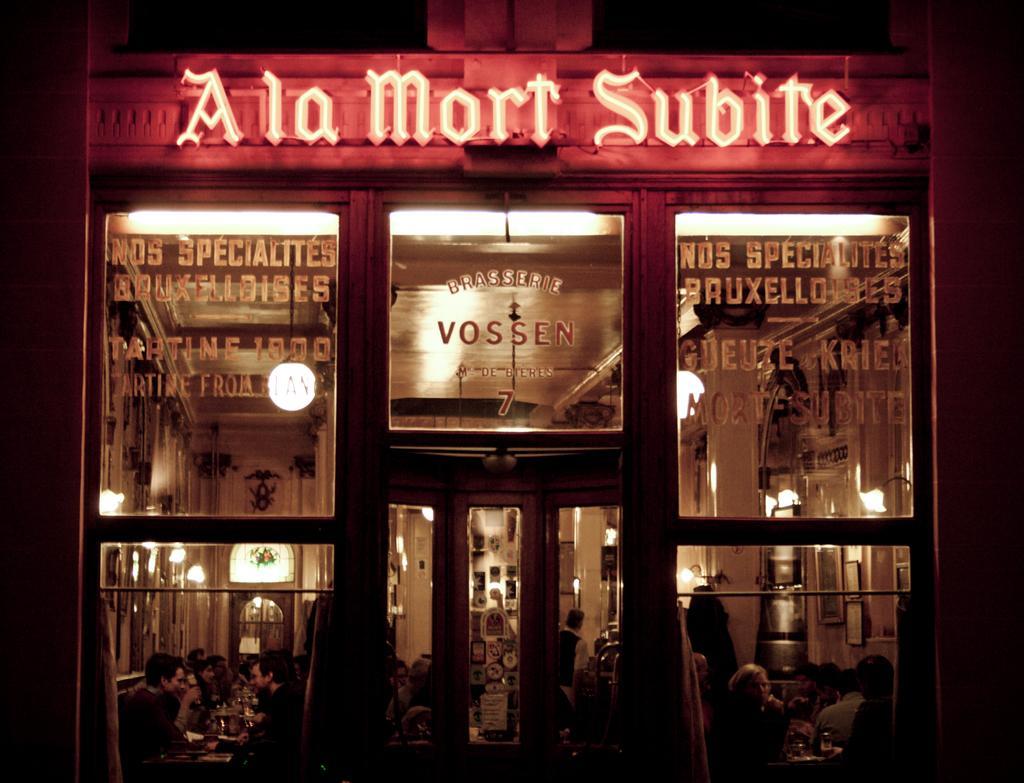Describe this image in one or two sentences. In this image, we can see some people inside the building. There are lights in the middle of the image. 